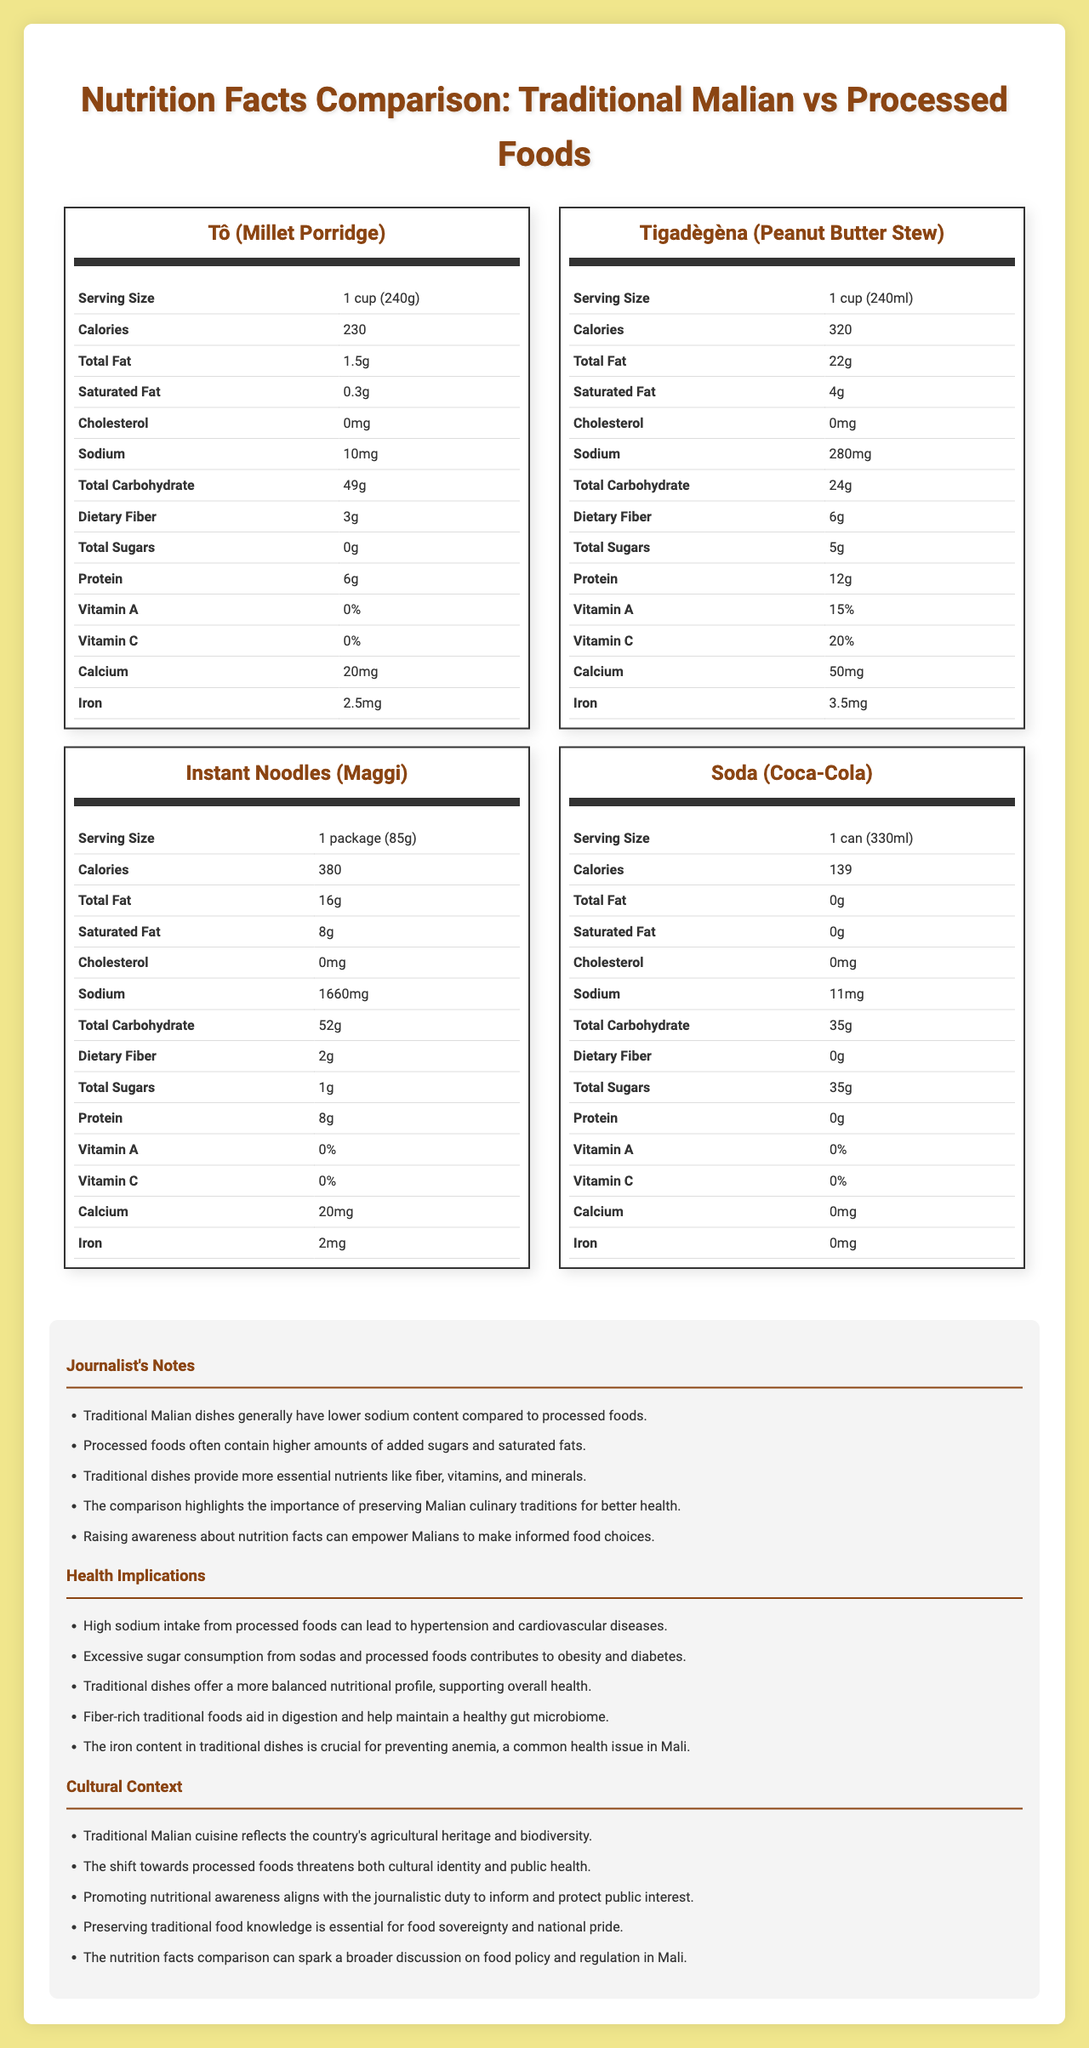what is the serving size of Tô (Millet Porridge)? The document specifies the serving size for Tô (Millet Porridge) as 1 cup (240g).
Answer: 1 cup (240g) Which traditional dish has the highest protein content? The data shows that Tigadègèna (Peanut Butter Stew) contains 12g of protein, which is higher compared to Tô (Millet Porridge) with 6g of protein.
Answer: Tigadègèna (Peanut Butter Stew) How much sodium is in one package of Instant Noodles (Maggi)? The information provided indicates that a package of Instant Noodles (Maggi) contains 1660mg of sodium.
Answer: 1660mg Does Tô (Millet Porridge) contain any sugars? According to the nutrition facts, Tô (Millet Porridge) contains 0g of total sugars.
Answer: No What is the total carbohydrate content in a can of Soda (Coca-Cola)? The document states that a can of Soda (Coca-Cola) contains 35g of total carbohydrates.
Answer: 35g Which of the following foods has the highest caloric value?
A. Tô (Millet Porridge)
B. Tigadègèna (Peanut Butter Stew)
C. Instant Noodles (Maggi)
D. Soda (Coca-Cola) The caloric values are: Tô (230 calories), Tigadègèna (320 calories), Instant Noodles (380 calories), Soda (139 calories). Instant Noodles have the highest caloric value.
Answer: C. Instant Noodles (Maggi) Which dish contains the most calcium?
1. Tô (Millet Porridge)
2. Tigadègèna (Peanut Butter Stew)
3. Instant Noodles (Maggi)
4. Soda (Coca-Cola) The calcium content is: Tô (20mg), Tigadègèna (50mg), Instant Noodles (20mg), Soda (0mg). Tigadègèna contains the most calcium.
Answer: 2. Tigadègèna (Peanut Butter Stew) Does Soda (Coca-Cola) have any dietary fiber? The nutrition facts for Soda (Coca-Cola) shows that it contains 0g of dietary fiber.
Answer: No How much saturated fat is in each serving of Tigadègèna (Peanut Butter Stew)? The data indicates that a serving of Tigadègèna (Peanut Butter Stew) contains 4g of saturated fat.
Answer: 4g Compare the sodium content of Tigadègèna (Peanut Butter Stew) and Instant Noodles (Maggi). Which contains more, and by how much? Tigadègèna contains 280mg of sodium, while Instant Noodles contains 1660mg. The difference is 1660mg - 280mg = 1380mg.
Answer: Instant Noodles (Maggi) contains 1380mg more sodium than Tigadègèna Describe the main idea of the document. The document presents detailed nutrition facts for Tô (Millet Porridge) and Tigadègèna (Peanut Butter Stew) as traditional Malian dishes, and Instant Noodles (Maggi) and Soda (Coca-Cola) as processed foods. It includes journalist notes and insights into health implications and cultural context, demonstrating how traditional dishes are nutritionally superior while processed foods often have higher sodium and sugar levels.
Answer: The document compares the nutritional facts of traditional Malian dishes with processed foods, highlighting differences in caloric values, fat content, sodium levels, and nutritional benefits. What are the recommended dietary allowances for iron? The document does not provide recommended dietary allowances for iron, only the iron content for each food item.
Answer: Cannot be determined 